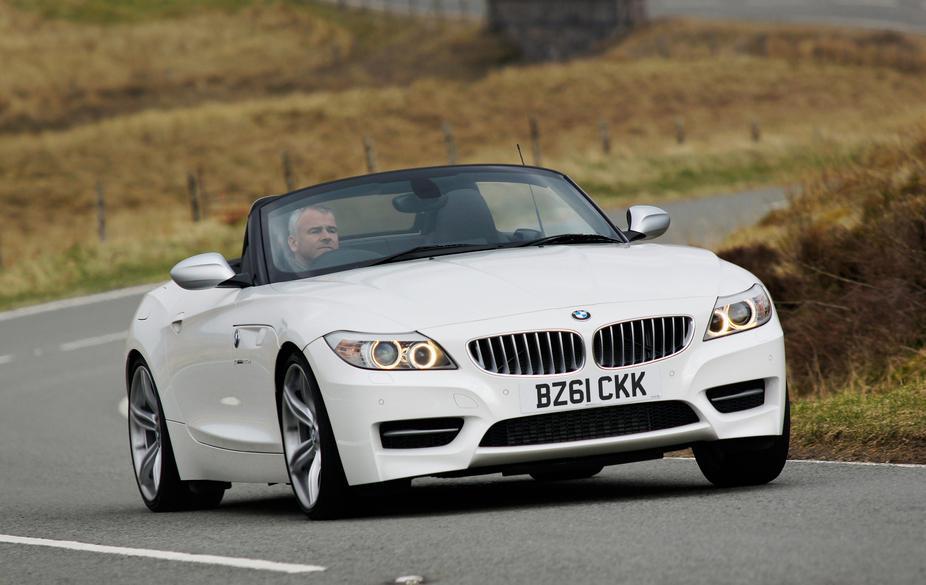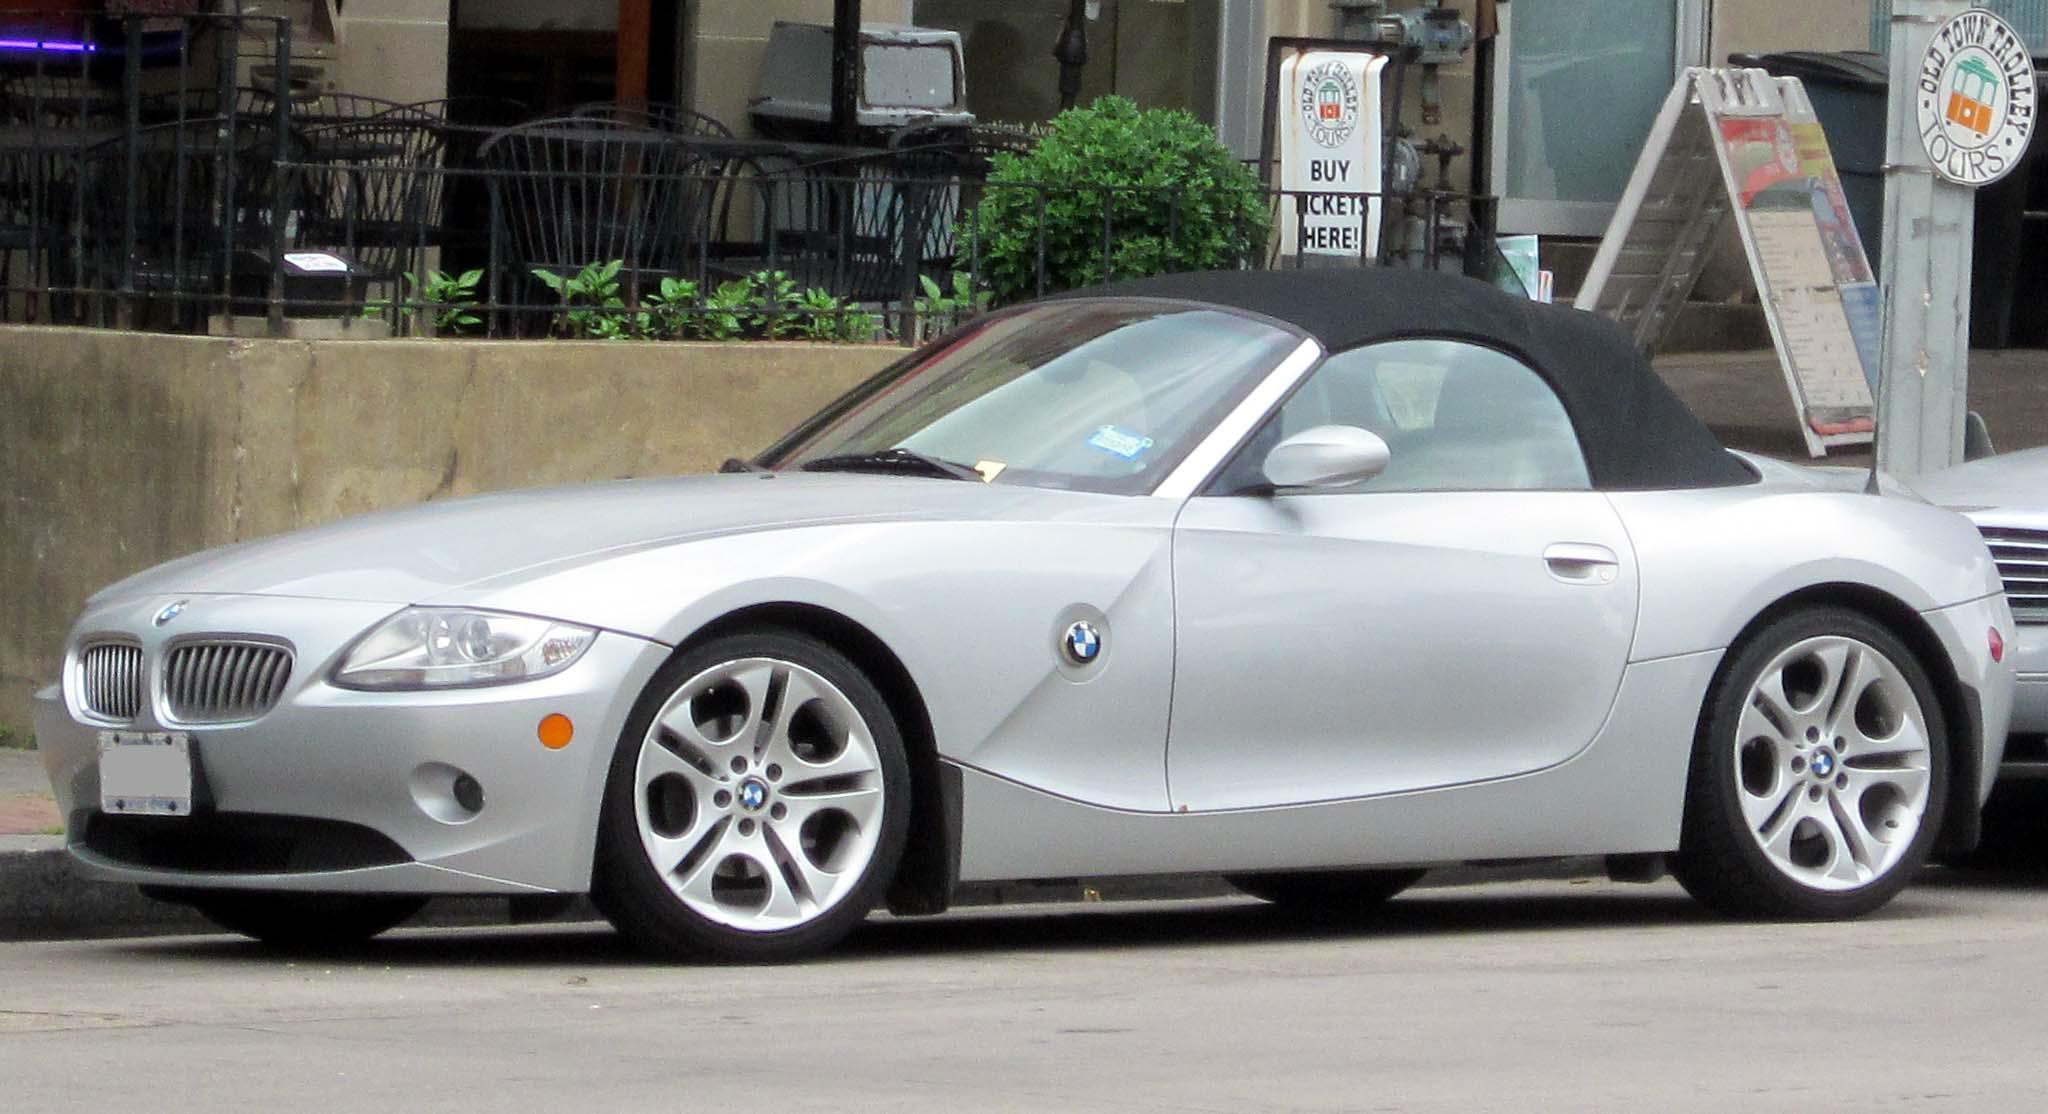The first image is the image on the left, the second image is the image on the right. For the images displayed, is the sentence "A body of water is in the background of a convertible in one of the images." factually correct? Answer yes or no. No. The first image is the image on the left, the second image is the image on the right. For the images displayed, is the sentence "One of the cars is red." factually correct? Answer yes or no. No. 